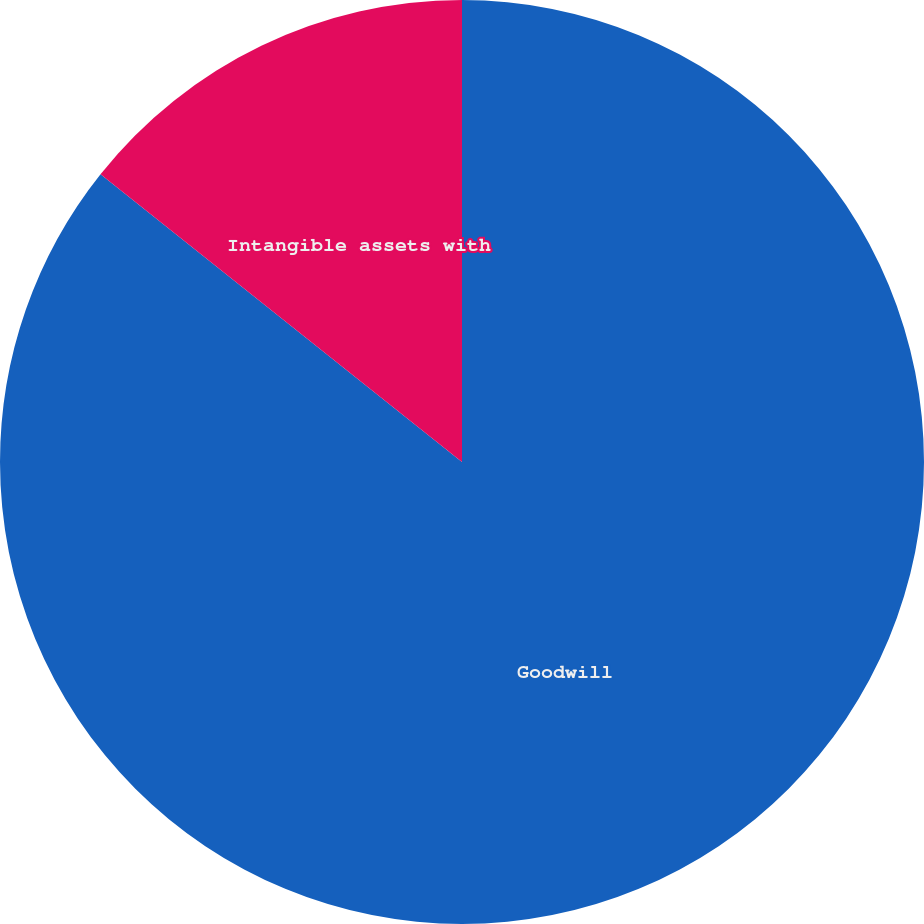Convert chart to OTSL. <chart><loc_0><loc_0><loc_500><loc_500><pie_chart><fcel>Goodwill<fcel>Intangible assets with<nl><fcel>85.7%<fcel>14.3%<nl></chart> 